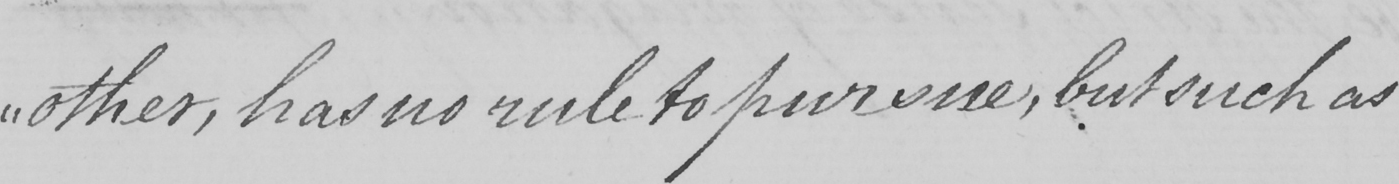Transcribe the text shown in this historical manuscript line. " other , has no rule to pursue , but such as 